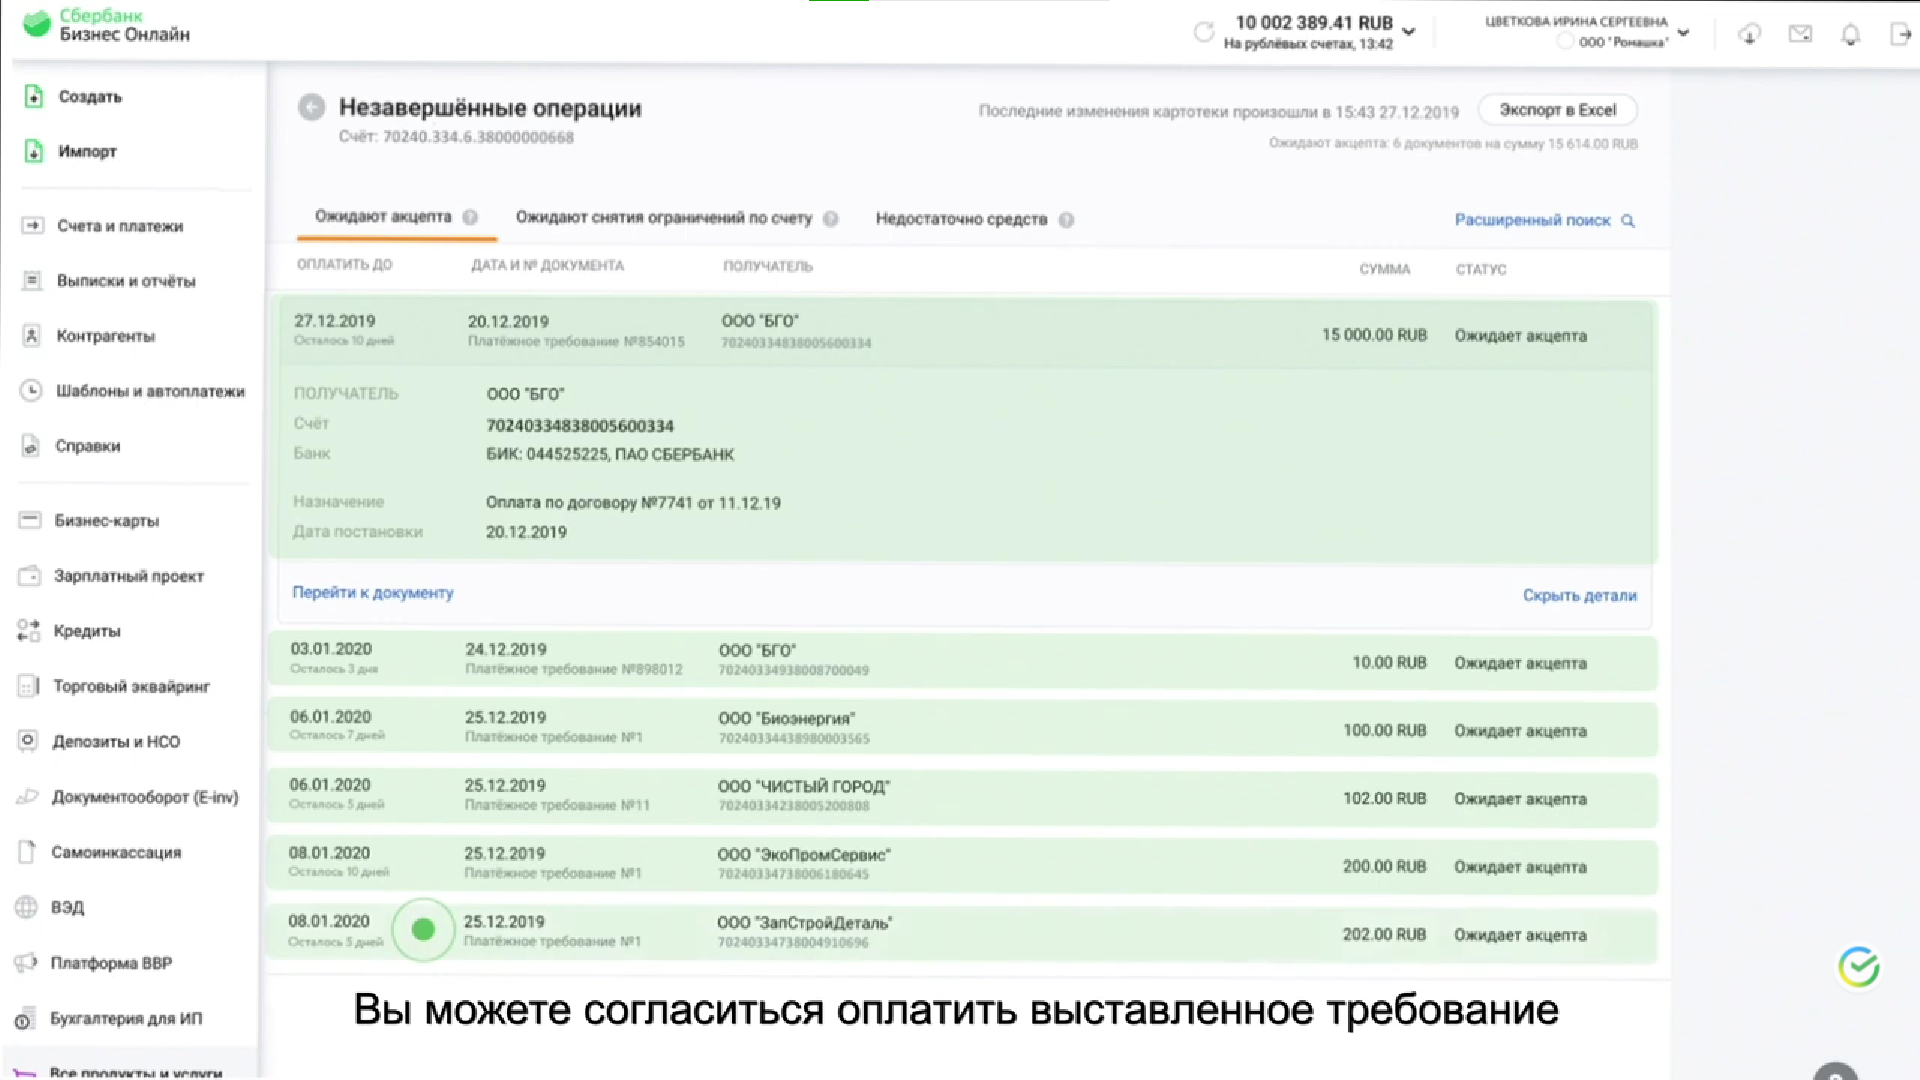Перечисли получателей незавершенных операций - ООО "БГ"
- ООО "Биоэнергия"
- ООО "Чистый город"
- ООО "ЭкпромСервис"
- ООО "ЗапСтройДеталь" 